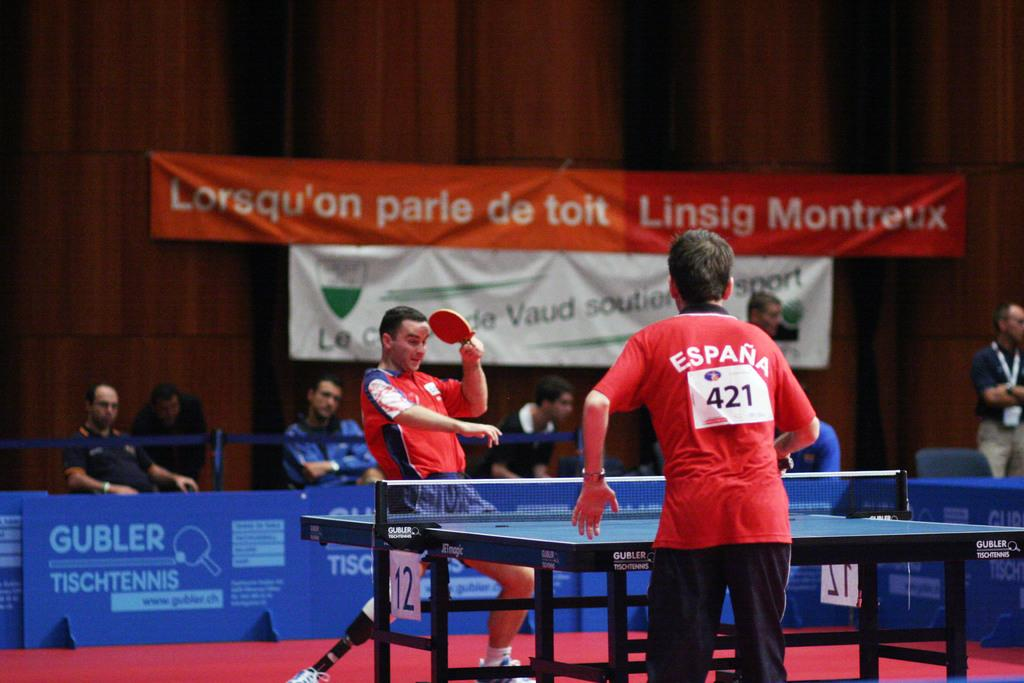<image>
Render a clear and concise summary of the photo. a person is wearing a jersey with the number 421 on it 